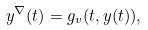Convert formula to latex. <formula><loc_0><loc_0><loc_500><loc_500>y ^ { \nabla } ( t ) = g _ { v } ( t , y ( t ) ) ,</formula> 